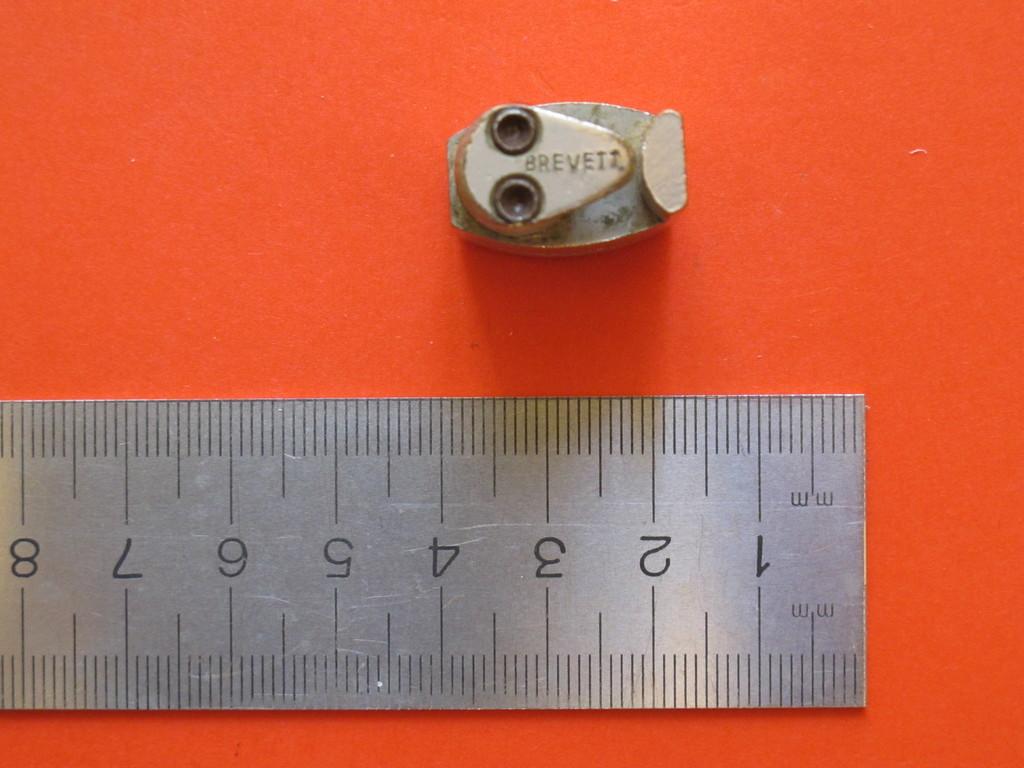How many inches are shown on the ruler?
Your answer should be very brief. 8. How many milimeters are shown on the ruler?
Keep it short and to the point. 8. 